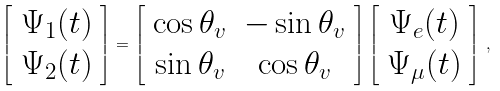Convert formula to latex. <formula><loc_0><loc_0><loc_500><loc_500>\left [ \begin{array} { c c } { { \Psi _ { 1 } ( t ) } } \\ { { \Psi _ { 2 } ( t ) } } \end{array} \right ] = \left [ \begin{array} { c c } { { \cos { \theta _ { v } } } } & { { - \sin { \theta _ { v } } } } \\ { { \sin { \theta _ { v } } } } & { { \cos { \theta _ { v } } } } \end{array} \right ] \left [ \begin{array} { c c } { { \Psi _ { e } ( t ) } } \\ { { \Psi _ { \mu } ( t ) } } \end{array} \right ] \, ,</formula> 